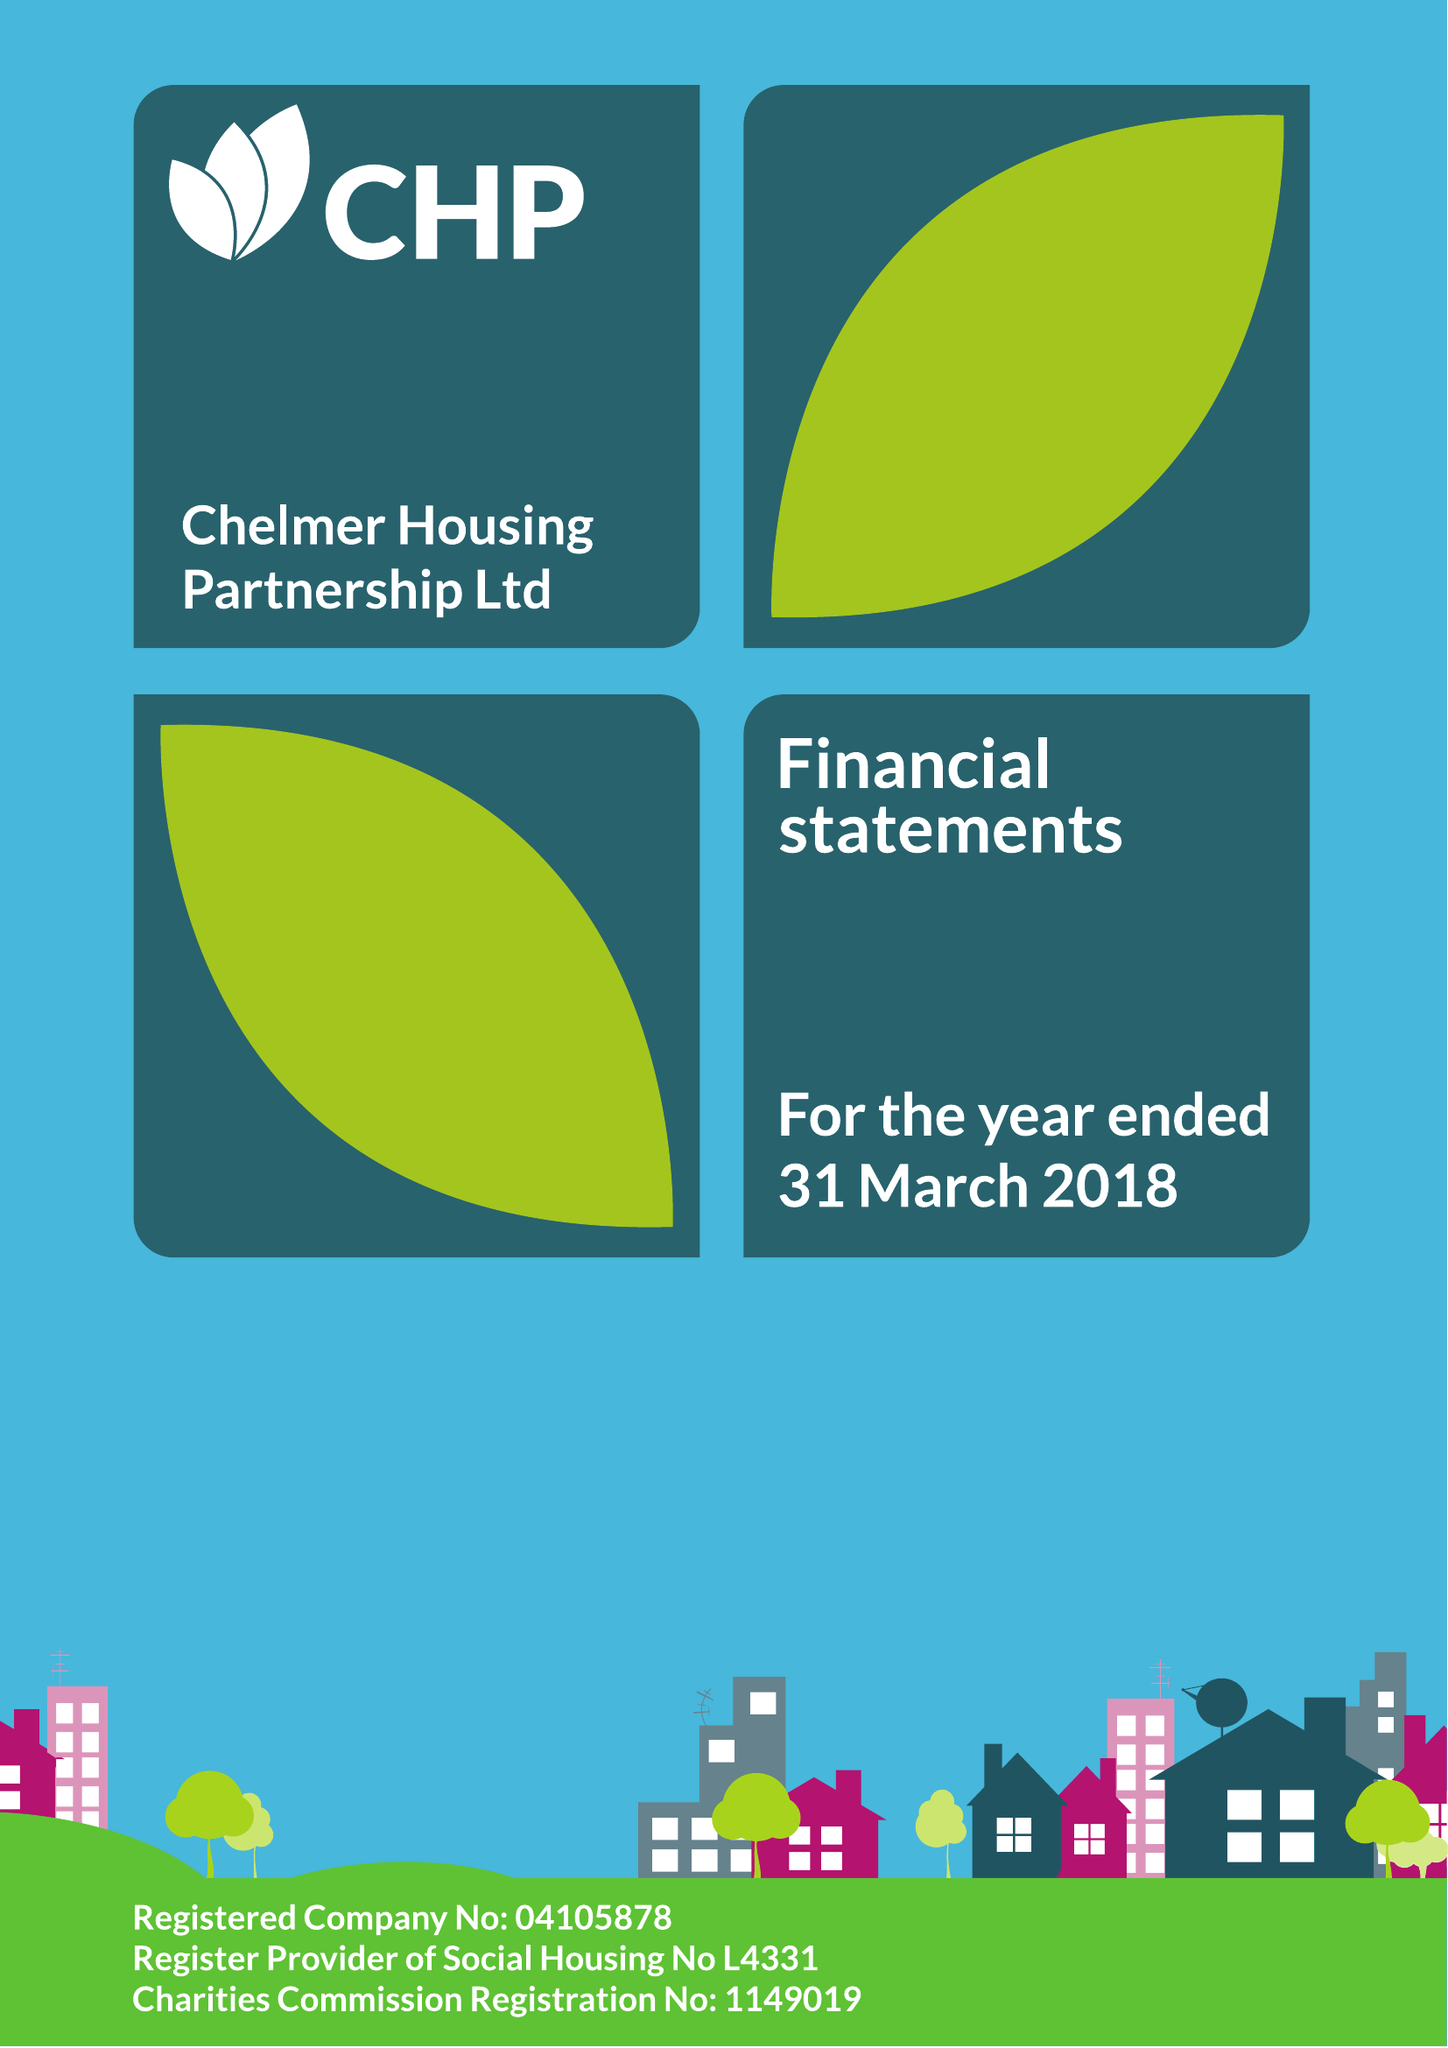What is the value for the spending_annually_in_british_pounds?
Answer the question using a single word or phrase. 71036000.00 